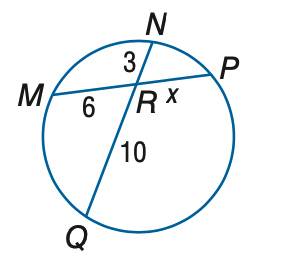Question: Find x to the nearest tenth. Assume that segments that appear to be tangent are tangent.
Choices:
A. 3
B. 4
C. 5
D. 6
Answer with the letter. Answer: C 